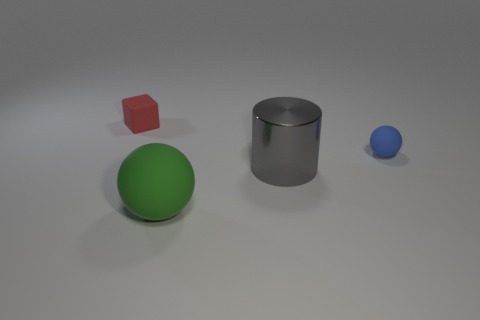Add 3 blue objects. How many objects exist? 7 Subtract all cylinders. How many objects are left? 3 Subtract all green rubber cylinders. Subtract all green balls. How many objects are left? 3 Add 1 small blue rubber things. How many small blue rubber things are left? 2 Add 3 small balls. How many small balls exist? 4 Subtract 0 purple spheres. How many objects are left? 4 